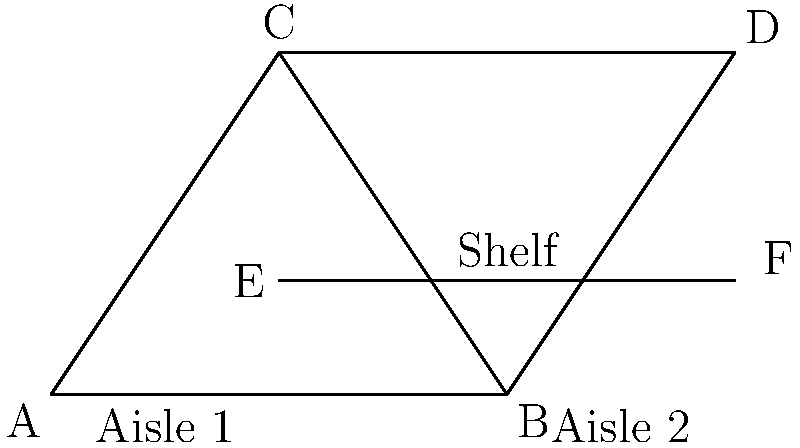In your grocery store layout, two triangles are formed by the aisles and shelving units as shown in the diagram. Triangle ABC represents the area between Aisle 1 and the shelf, while triangle BCD represents the area between Aisle 2 and the shelf. If AB = 4 meters, BC = 5 meters, AD = 6 meters, and angle ABC = angle BCD, prove that triangles ABC and BCD are congruent. To prove that triangles ABC and BCD are congruent, we'll use the AAS (Angle-Angle-Side) congruence criterion. Let's proceed step-by-step:

1) Given: 
   - AB = 4 meters
   - BC = 5 meters
   - AD = 6 meters
   - ∠ABC = ∠BCD

2) Step 1: Prove that ∠BAC = ∠BDC
   - In triangle ABD, AD = 6m and AB = 4m
   - Therefore, BD = AD - AB = 6m - 4m = 2m
   - This means that BD = BC (both are 2m)
   - In triangle BCD, since BD = BC, ∠BDC = ∠BCD (angles opposite equal sides)
   - But ∠BCD = ∠ABC (given)
   - Therefore, ∠BDC = ∠ABC
   - In triangle ABC, ∠BAC + ∠ABC + ∠BCA = 180° (angle sum of triangle)
   - Similarly, in triangle BCD, ∠BDC + ∠BCD + ∠CBD = 180°
   - Since ∠BDC = ∠ABC and ∠BCD = ∠ABC, we can conclude that ∠BAC = ∠CBD

3) Step 2: Apply AAS congruence criterion
   - Angle: ∠BAC = ∠CBD (proved in step 1)
   - Angle: ∠ABC = ∠BCD (given)
   - Side: BC is common to both triangles

4) Therefore, by the AAS congruence criterion, triangle ABC is congruent to triangle BCD.
Answer: Triangles ABC and BCD are congruent by AAS criterion. 